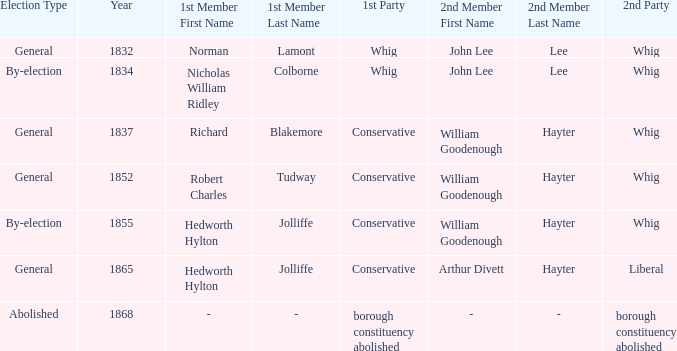What's the party of 2nd member arthur divett hayter when the 1st party is conservative? Liberal. 